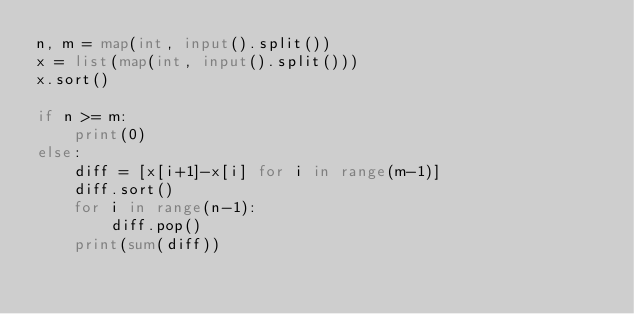<code> <loc_0><loc_0><loc_500><loc_500><_Python_>n, m = map(int, input().split())
x = list(map(int, input().split()))
x.sort()

if n >= m:
    print(0)
else:
    diff = [x[i+1]-x[i] for i in range(m-1)]
    diff.sort()
    for i in range(n-1):
        diff.pop()
    print(sum(diff))</code> 